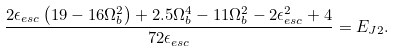Convert formula to latex. <formula><loc_0><loc_0><loc_500><loc_500>& \frac { 2 \epsilon _ { e s c } \left ( 1 9 - 1 6 \Omega _ { b } ^ { 2 } \right ) + 2 . 5 \Omega _ { b } ^ { 4 } - 1 1 \Omega _ { b } ^ { 2 } - 2 \epsilon _ { e s c } ^ { 2 } + 4 } { 7 2 \epsilon _ { e s c } } = E _ { J 2 } . &</formula> 